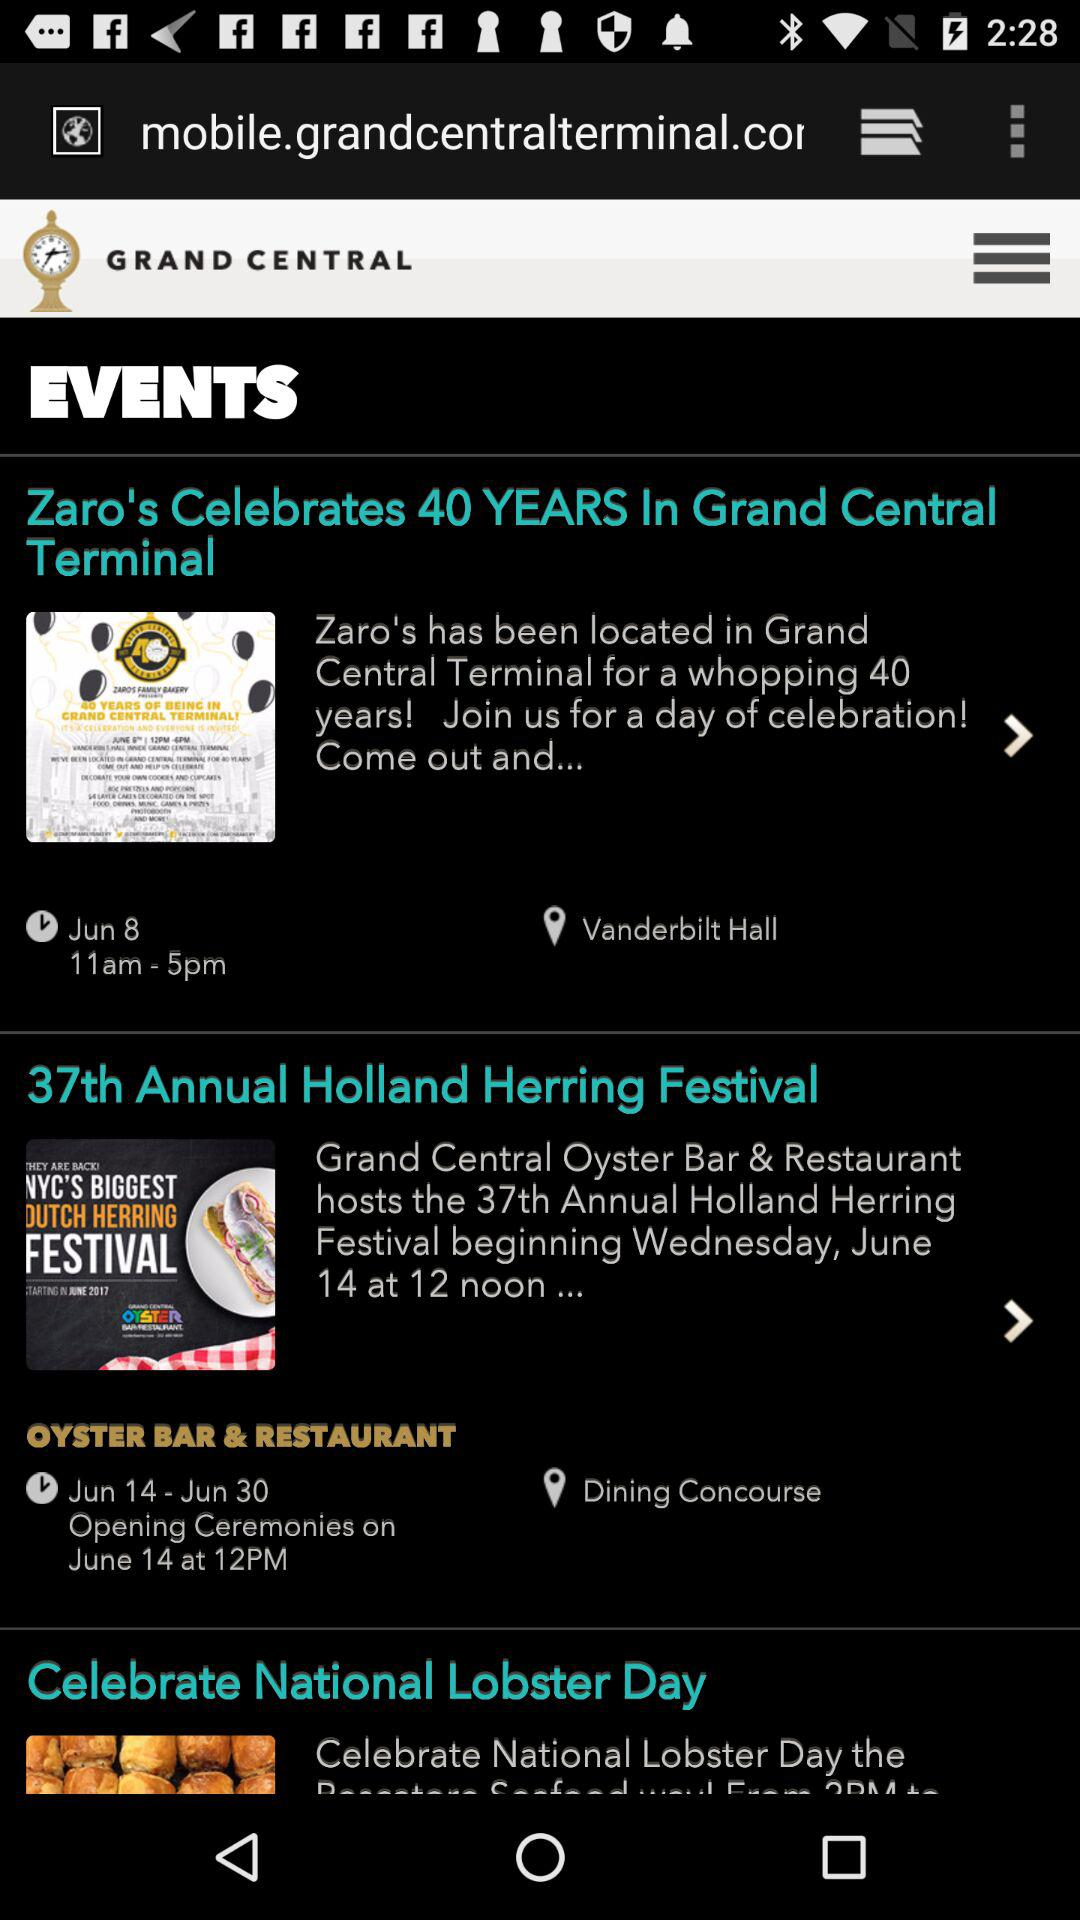What is the date of the "37th Annual Holland Herring Festival"? The date is June 14 to June 30. 